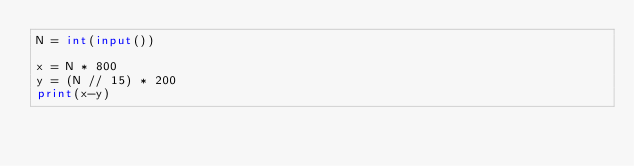Convert code to text. <code><loc_0><loc_0><loc_500><loc_500><_Python_>N = int(input())

x = N * 800
y = (N // 15) * 200
print(x-y)</code> 